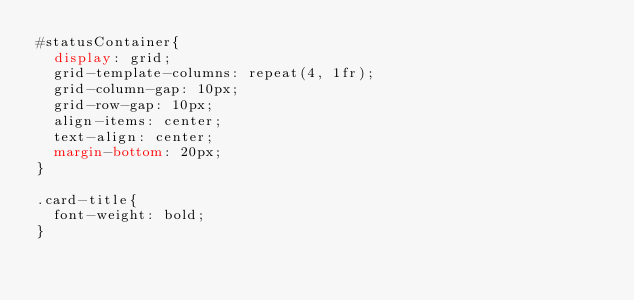<code> <loc_0><loc_0><loc_500><loc_500><_CSS_>#statusContainer{
	display: grid;
	grid-template-columns: repeat(4, 1fr);
	grid-column-gap: 10px;
	grid-row-gap: 10px;
	align-items: center;
	text-align: center;
	margin-bottom: 20px;
}
	
.card-title{
	font-weight: bold;
}</code> 